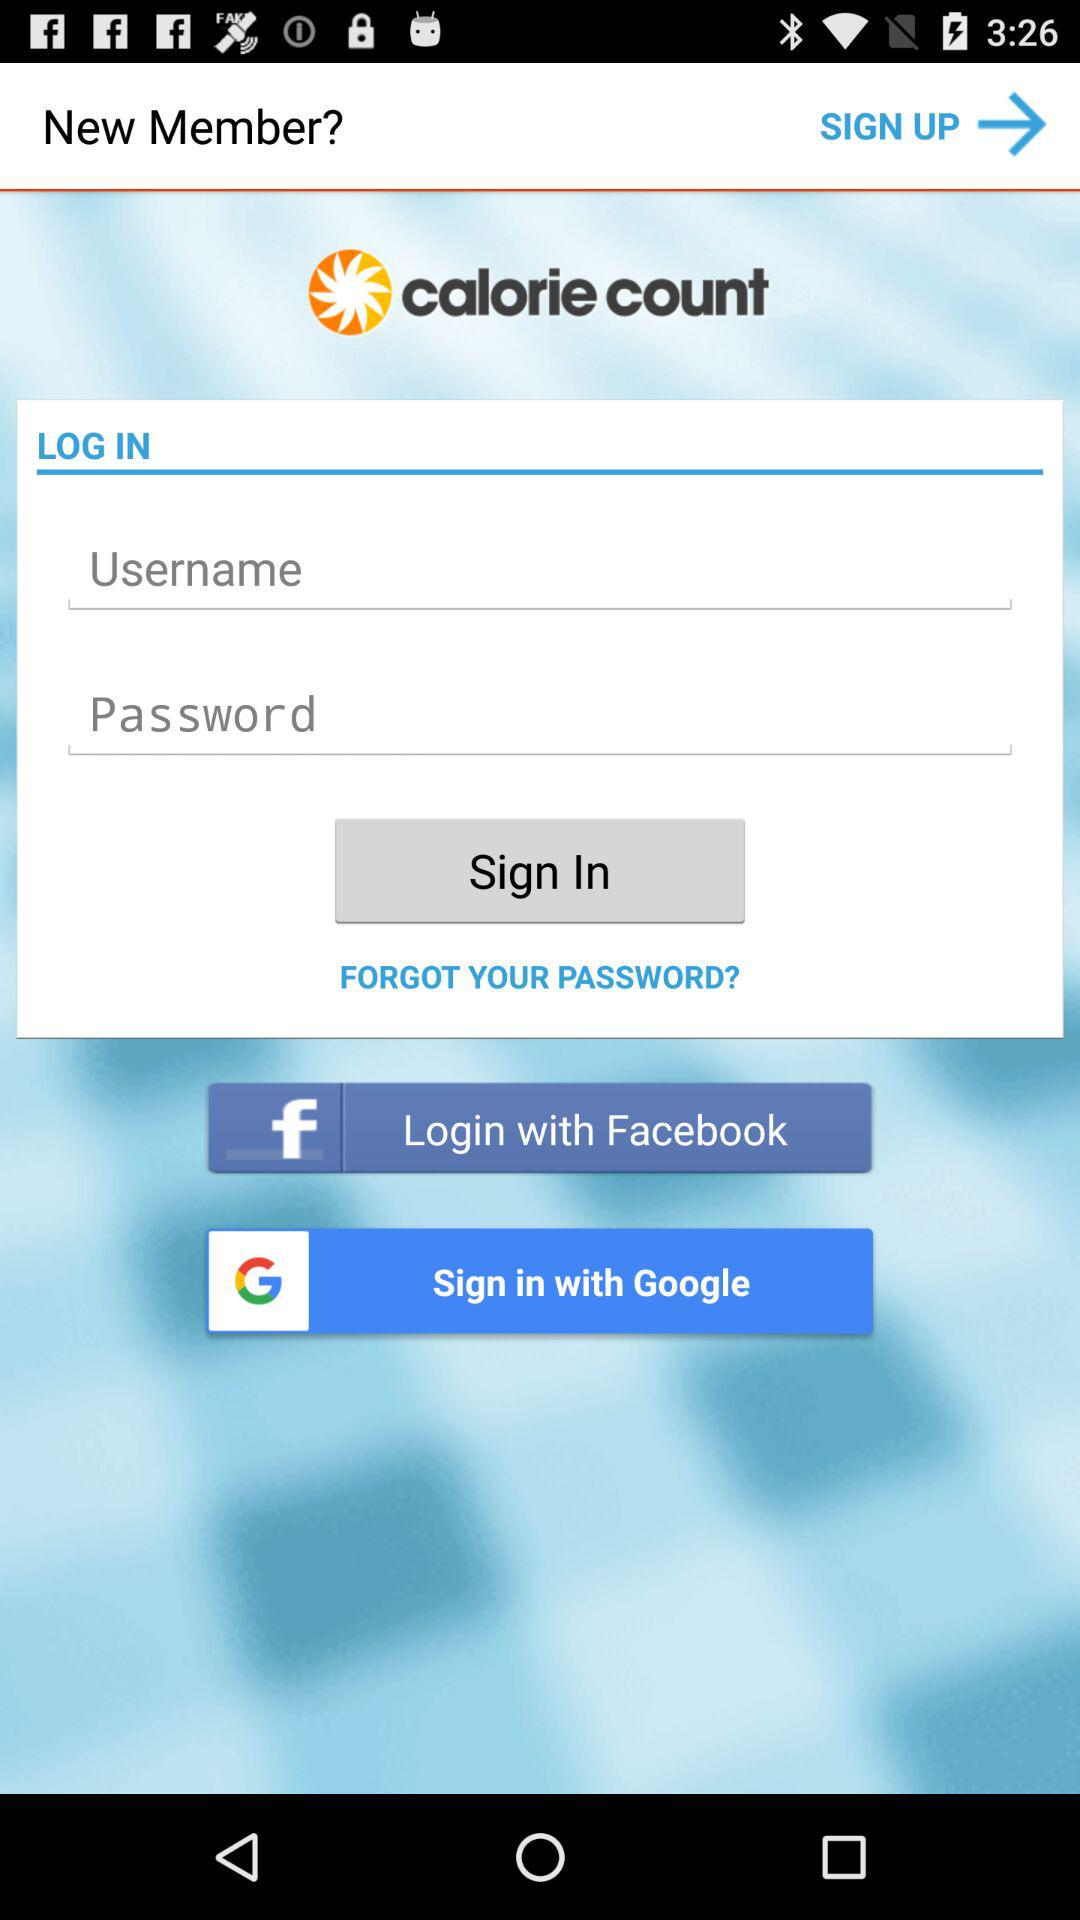What are the different applications through which we can sign in? The different application through which we can sign in is "Google". 